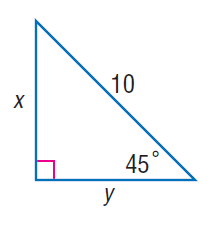Answer the mathemtical geometry problem and directly provide the correct option letter.
Question: Find y.
Choices: A: 5 B: 5 \sqrt { 2 } C: 10 D: 10 \sqrt { 2 } B 